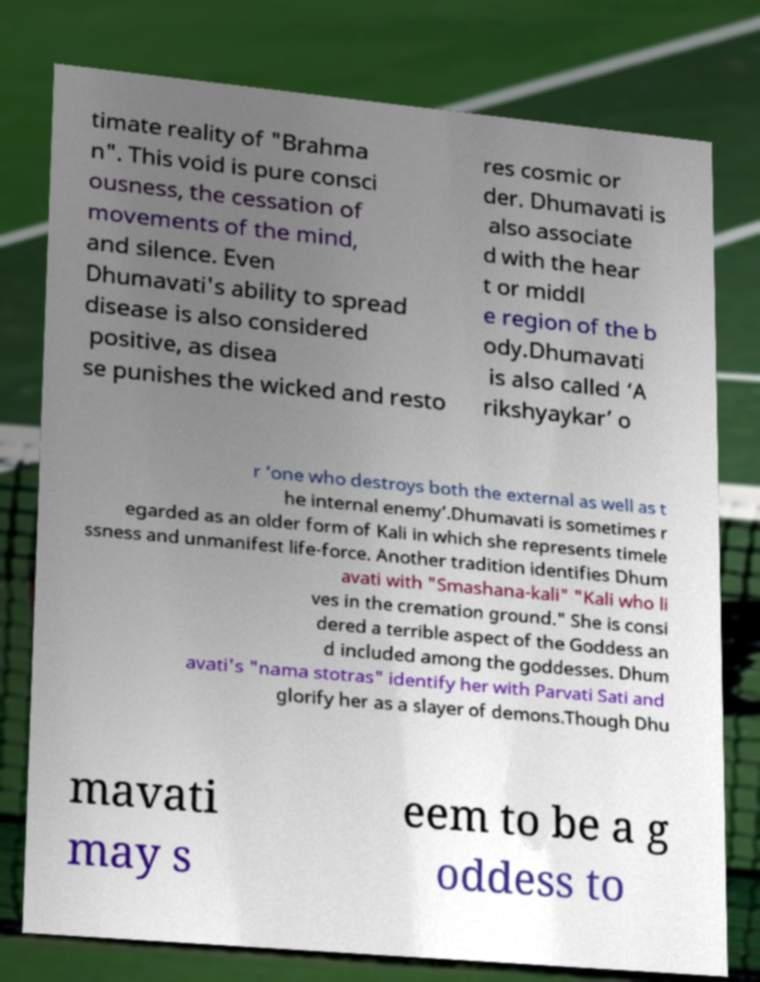Can you accurately transcribe the text from the provided image for me? timate reality of "Brahma n". This void is pure consci ousness, the cessation of movements of the mind, and silence. Even Dhumavati's ability to spread disease is also considered positive, as disea se punishes the wicked and resto res cosmic or der. Dhumavati is also associate d with the hear t or middl e region of the b ody.Dhumavati is also called ‘A rikshyaykar’ o r ‘one who destroys both the external as well as t he internal enemy’.Dhumavati is sometimes r egarded as an older form of Kali in which she represents timele ssness and unmanifest life-force. Another tradition identifies Dhum avati with "Smashana-kali" "Kali who li ves in the cremation ground." She is consi dered a terrible aspect of the Goddess an d included among the goddesses. Dhum avati's "nama stotras" identify her with Parvati Sati and glorify her as a slayer of demons.Though Dhu mavati may s eem to be a g oddess to 